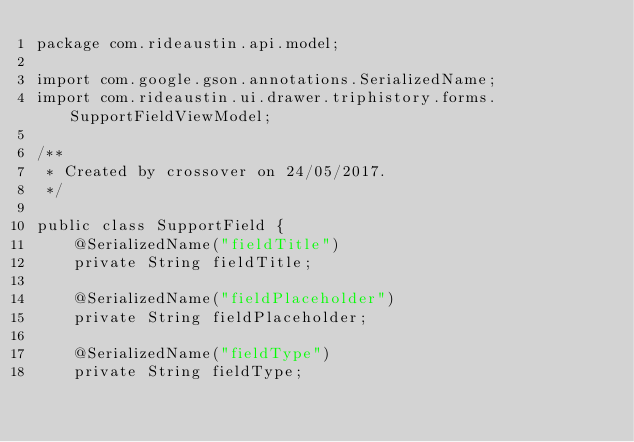Convert code to text. <code><loc_0><loc_0><loc_500><loc_500><_Java_>package com.rideaustin.api.model;

import com.google.gson.annotations.SerializedName;
import com.rideaustin.ui.drawer.triphistory.forms.SupportFieldViewModel;

/**
 * Created by crossover on 24/05/2017.
 */

public class SupportField {
    @SerializedName("fieldTitle")
    private String fieldTitle;

    @SerializedName("fieldPlaceholder")
    private String fieldPlaceholder;

    @SerializedName("fieldType")
    private String fieldType;
</code> 